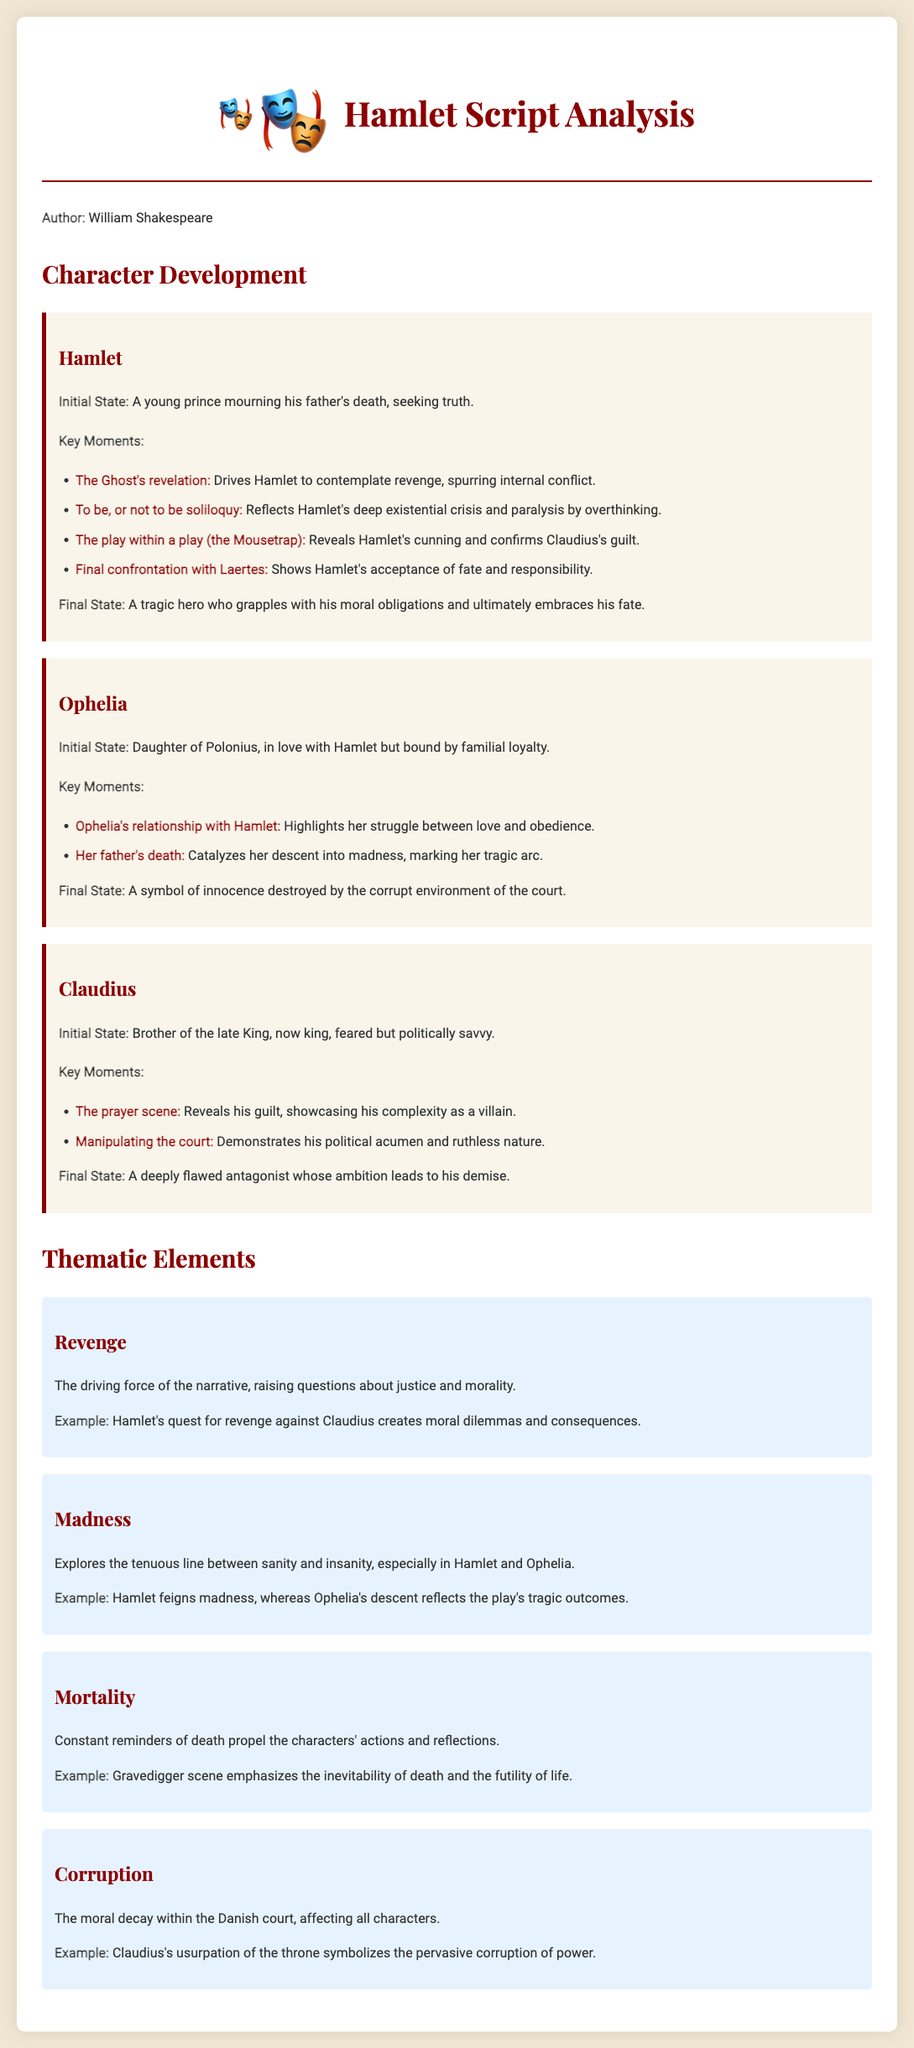What is the title of the play analyzed? The title is specifically mentioned in the header of the document.
Answer: Hamlet Who is the author of the play? The author's name is noted prominently in the document.
Answer: William Shakespeare What is Hamlet's initial state? The initial state of Hamlet is described at the beginning of his section.
Answer: A young prince mourning his father's death, seeking truth What does Ophelia symbolize at the end of the play? The final state of Ophelia provides insight into her symbolic representation after her character arc.
Answer: A symbol of innocence destroyed by the corrupt environment of the court Which character displays a struggle between love and obedience? The document highlights this internal conflict within a specific character's overview.
Answer: Ophelia What thematic element is a driving force of the narrative? The thematic analysis section categorizes the elements that propel the story, with one being specifically emphasized.
Answer: Revenge How does Claudius reveal his guilt? The document notes a specific scene where Claudius's feelings are showcased.
Answer: The prayer scene What dilemma does Hamlet's quest for revenge create? The document mentions the repercussions of Hamlet's actions in relation to a key thematic element.
Answer: Moral dilemmas and consequences What scene emphasizes the inevitability of death? The document provides specific examples discussing the theme of mortality, pointing to this particular scene.
Answer: Gravedigger scene 